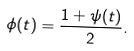Convert formula to latex. <formula><loc_0><loc_0><loc_500><loc_500>\phi ( t ) = \frac { 1 + \psi ( t ) } { 2 } .</formula> 